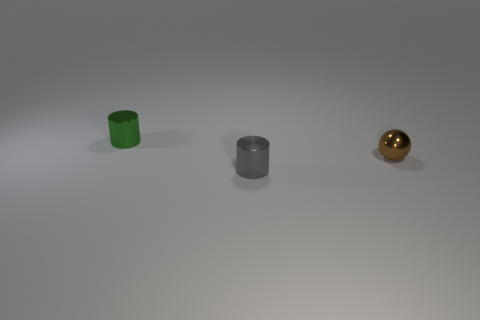Add 3 balls. How many objects exist? 6 Subtract all cylinders. How many objects are left? 1 Add 3 small brown spheres. How many small brown spheres are left? 4 Add 2 green metallic spheres. How many green metallic spheres exist? 2 Subtract 0 yellow blocks. How many objects are left? 3 Subtract all tiny brown metallic spheres. Subtract all gray metal cylinders. How many objects are left? 1 